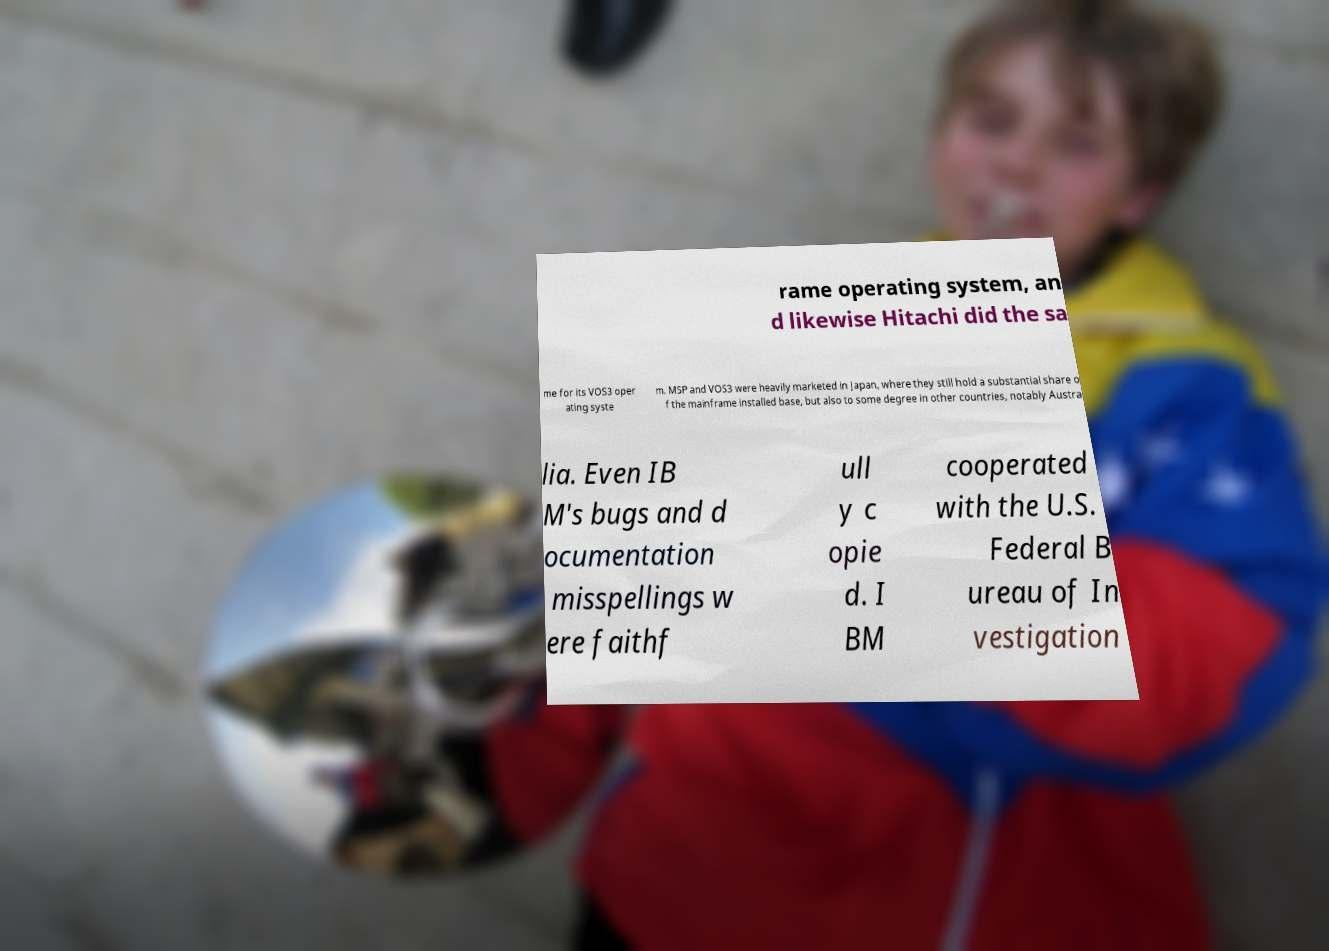Can you accurately transcribe the text from the provided image for me? rame operating system, an d likewise Hitachi did the sa me for its VOS3 oper ating syste m. MSP and VOS3 were heavily marketed in Japan, where they still hold a substantial share o f the mainframe installed base, but also to some degree in other countries, notably Austra lia. Even IB M's bugs and d ocumentation misspellings w ere faithf ull y c opie d. I BM cooperated with the U.S. Federal B ureau of In vestigation 